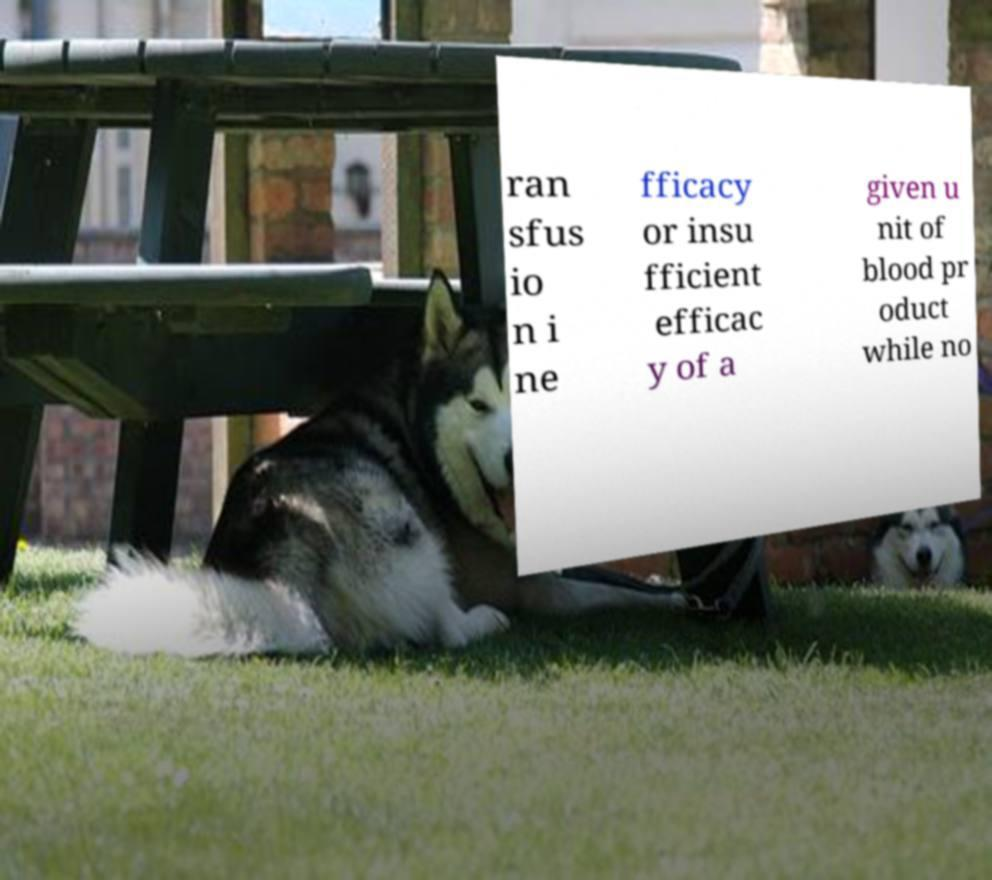Can you read and provide the text displayed in the image?This photo seems to have some interesting text. Can you extract and type it out for me? ran sfus io n i ne fficacy or insu fficient efficac y of a given u nit of blood pr oduct while no 